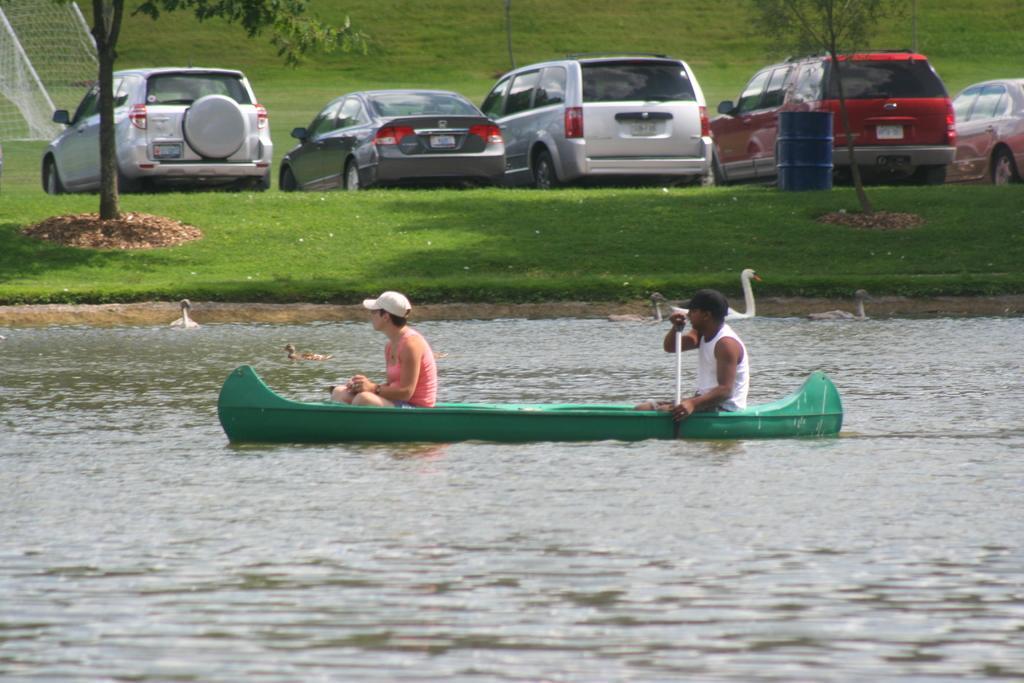Can you describe this image briefly? In this image at the bottom there is a lake, and in the lake there is a boat and in the boat there are two persons who are sitting and one person is holding something. And also there are some swans in the river, in the background there are some vehicles, drum, trees, net and grass. 